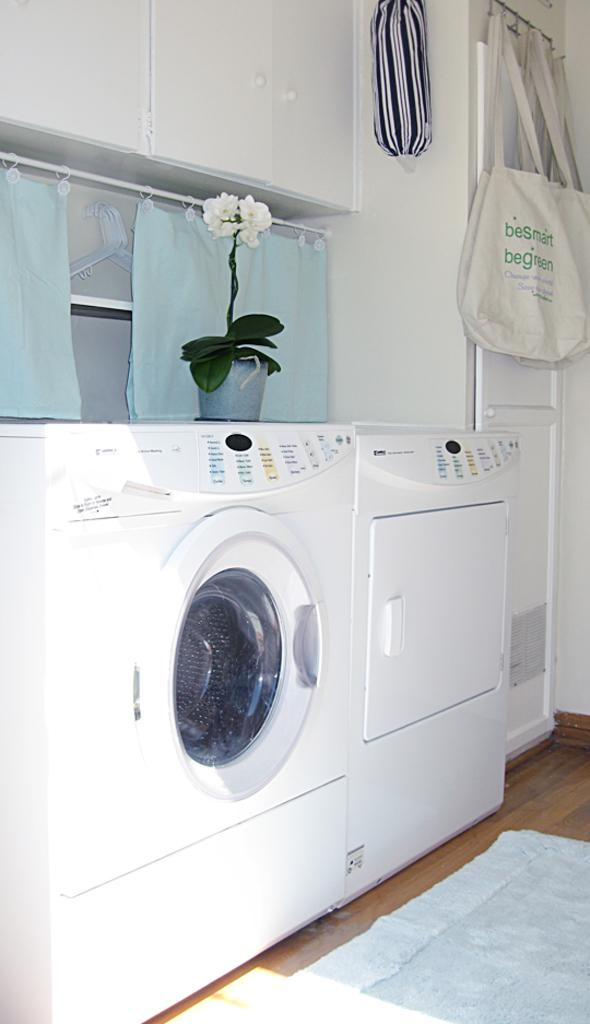What appliance can be seen in the image? There is a washing machine in the image. What items are hanging on the hanger? There are carry bags hanged on a hanger in the image. What type of plant is present in the image? There is a house plant in the image. What is on the floor in the image? There is a mat on the floor in the image. What time is displayed on the washing machine in the image? There is no time displayed on the washing machine in the image. What type of shirt is hanging on the hanger in the image? There are no shirts present in the image; only carry bags are hanging on the hanger. 